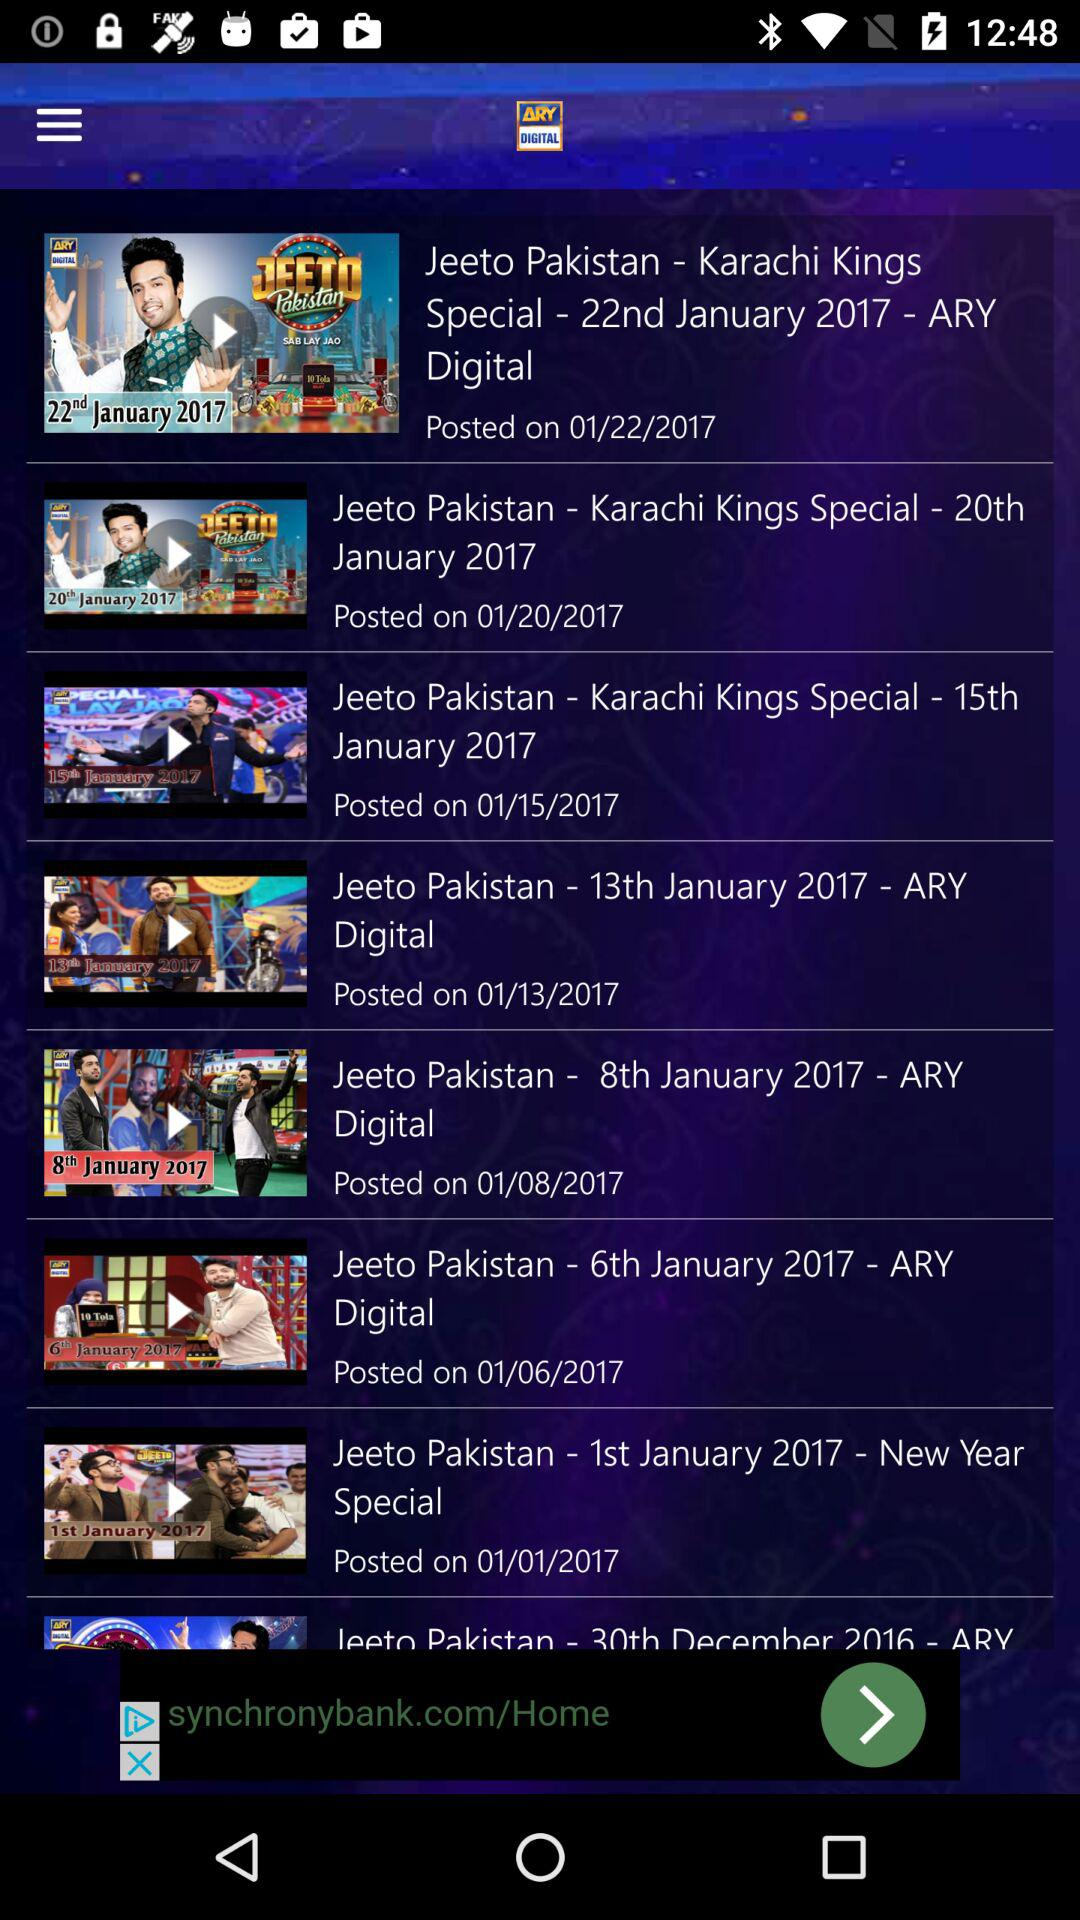On January 15th, 2017, which episode of Jeeto Pakistan aired? The episode was "Karachi Kings Special". 